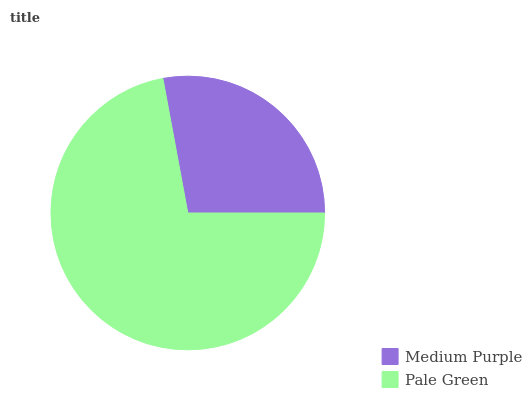Is Medium Purple the minimum?
Answer yes or no. Yes. Is Pale Green the maximum?
Answer yes or no. Yes. Is Pale Green the minimum?
Answer yes or no. No. Is Pale Green greater than Medium Purple?
Answer yes or no. Yes. Is Medium Purple less than Pale Green?
Answer yes or no. Yes. Is Medium Purple greater than Pale Green?
Answer yes or no. No. Is Pale Green less than Medium Purple?
Answer yes or no. No. Is Pale Green the high median?
Answer yes or no. Yes. Is Medium Purple the low median?
Answer yes or no. Yes. Is Medium Purple the high median?
Answer yes or no. No. Is Pale Green the low median?
Answer yes or no. No. 